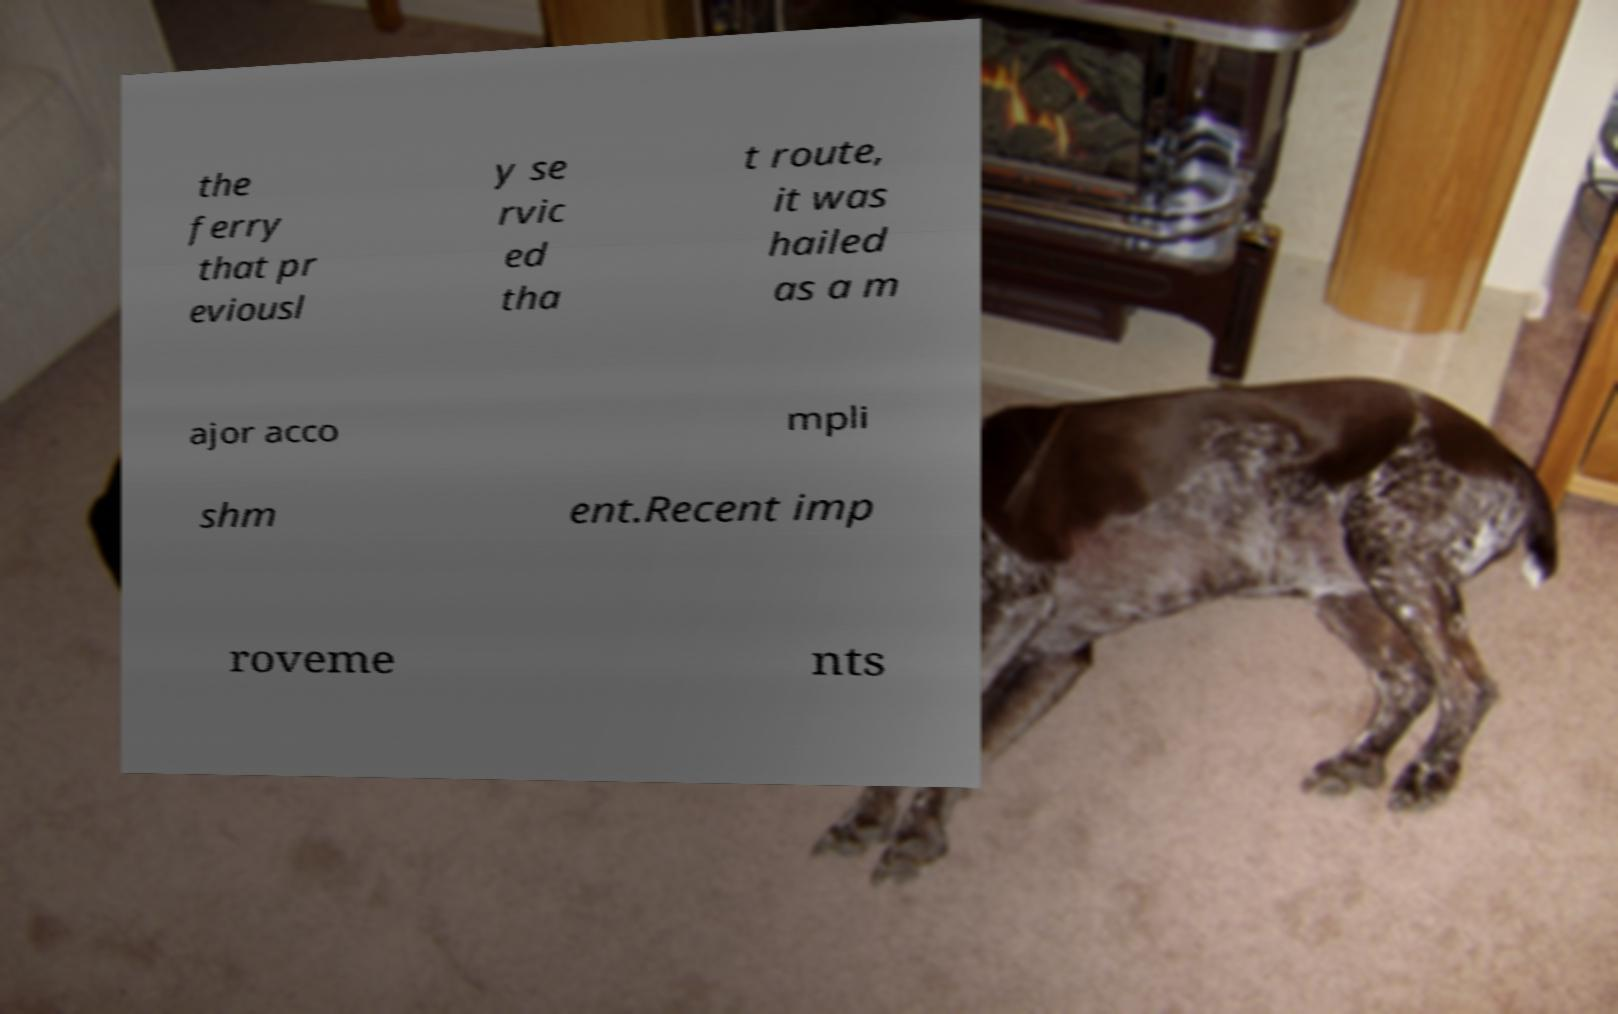What messages or text are displayed in this image? I need them in a readable, typed format. the ferry that pr eviousl y se rvic ed tha t route, it was hailed as a m ajor acco mpli shm ent.Recent imp roveme nts 